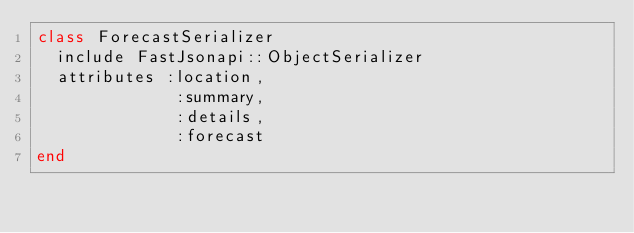Convert code to text. <code><loc_0><loc_0><loc_500><loc_500><_Ruby_>class ForecastSerializer
  include FastJsonapi::ObjectSerializer
  attributes :location,
              :summary,
              :details,
              :forecast
end
</code> 